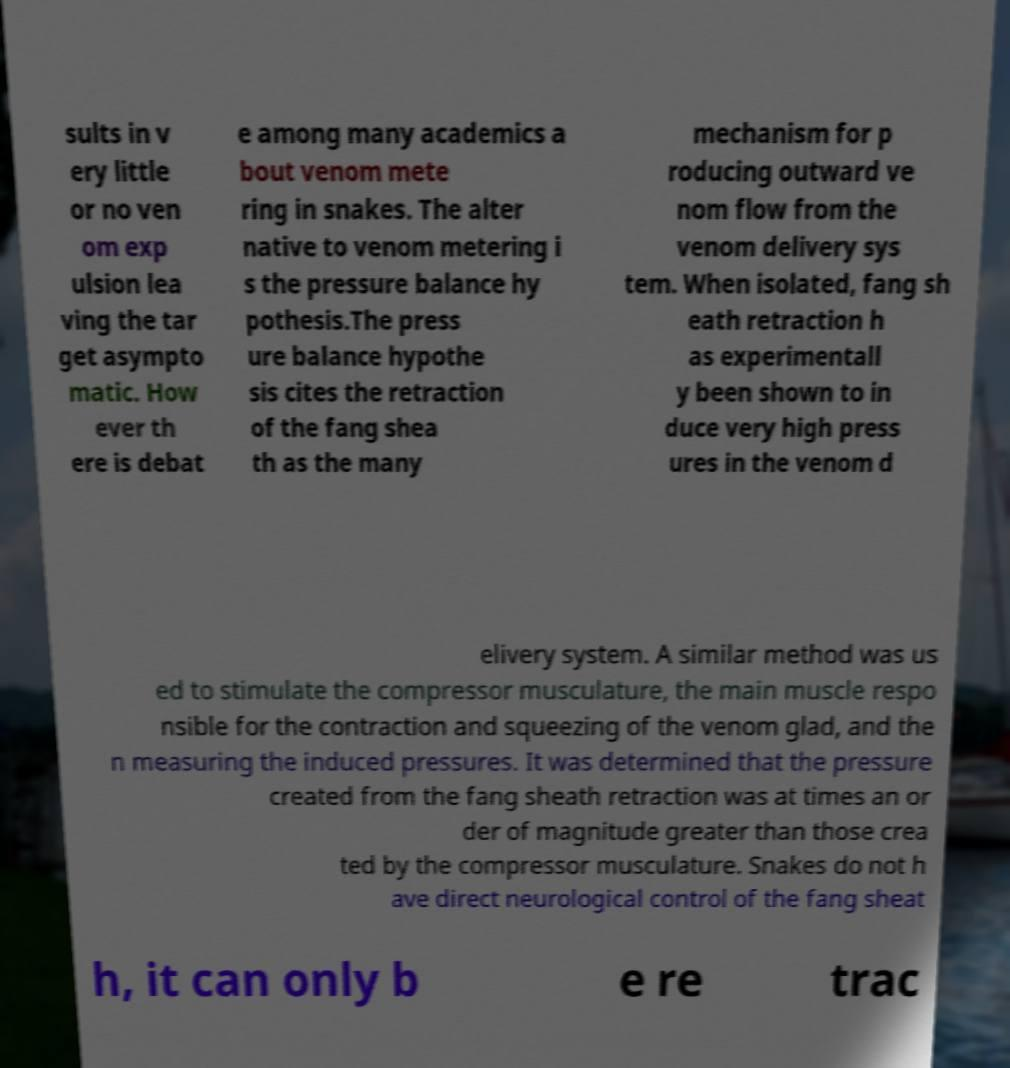There's text embedded in this image that I need extracted. Can you transcribe it verbatim? sults in v ery little or no ven om exp ulsion lea ving the tar get asympto matic. How ever th ere is debat e among many academics a bout venom mete ring in snakes. The alter native to venom metering i s the pressure balance hy pothesis.The press ure balance hypothe sis cites the retraction of the fang shea th as the many mechanism for p roducing outward ve nom flow from the venom delivery sys tem. When isolated, fang sh eath retraction h as experimentall y been shown to in duce very high press ures in the venom d elivery system. A similar method was us ed to stimulate the compressor musculature, the main muscle respo nsible for the contraction and squeezing of the venom glad, and the n measuring the induced pressures. It was determined that the pressure created from the fang sheath retraction was at times an or der of magnitude greater than those crea ted by the compressor musculature. Snakes do not h ave direct neurological control of the fang sheat h, it can only b e re trac 